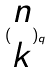Convert formula to latex. <formula><loc_0><loc_0><loc_500><loc_500>( \begin{matrix} n \\ k \end{matrix} ) _ { q }</formula> 